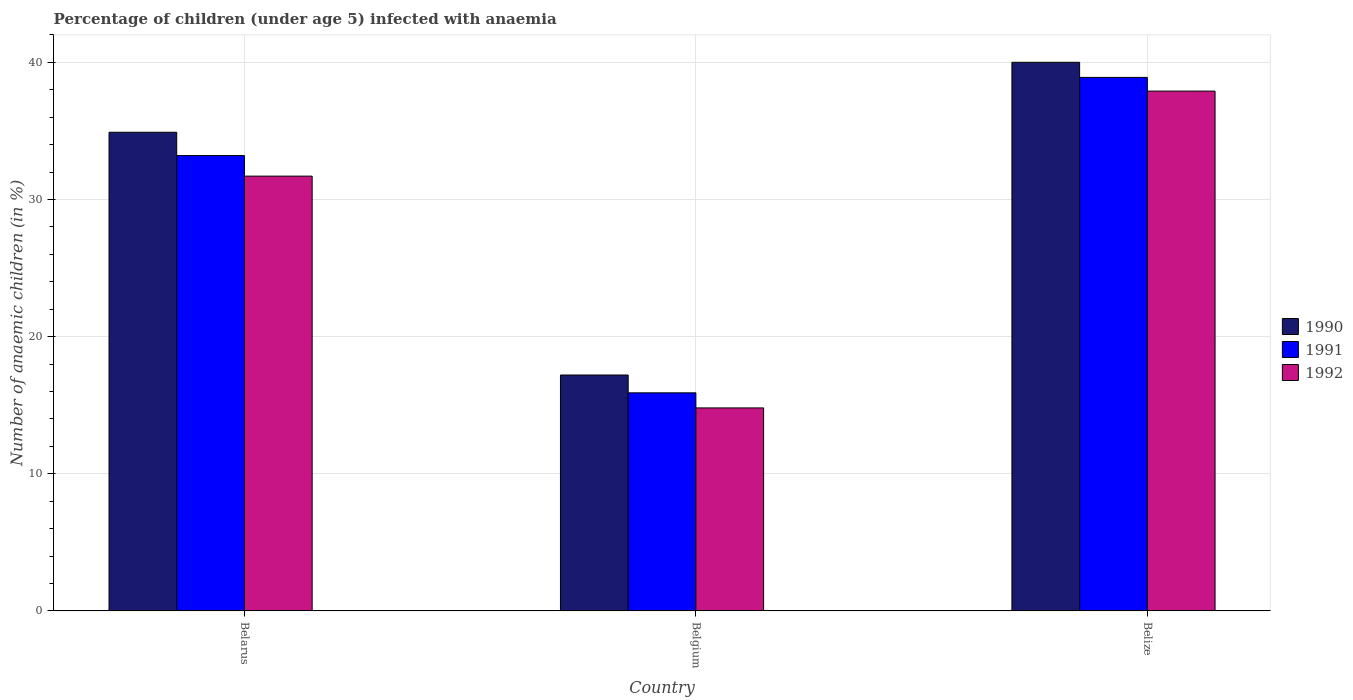Are the number of bars per tick equal to the number of legend labels?
Provide a short and direct response. Yes. How many bars are there on the 3rd tick from the left?
Keep it short and to the point. 3. How many bars are there on the 1st tick from the right?
Ensure brevity in your answer.  3. What is the label of the 3rd group of bars from the left?
Your answer should be very brief. Belize. What is the percentage of children infected with anaemia in in 1992 in Belize?
Provide a short and direct response. 37.9. Across all countries, what is the maximum percentage of children infected with anaemia in in 1992?
Make the answer very short. 37.9. Across all countries, what is the minimum percentage of children infected with anaemia in in 1992?
Your response must be concise. 14.8. In which country was the percentage of children infected with anaemia in in 1992 maximum?
Make the answer very short. Belize. What is the total percentage of children infected with anaemia in in 1990 in the graph?
Offer a very short reply. 92.1. What is the difference between the percentage of children infected with anaemia in in 1990 in Belarus and that in Belize?
Your answer should be very brief. -5.1. What is the average percentage of children infected with anaemia in in 1992 per country?
Ensure brevity in your answer.  28.13. What is the difference between the percentage of children infected with anaemia in of/in 1992 and percentage of children infected with anaemia in of/in 1990 in Belgium?
Provide a short and direct response. -2.4. In how many countries, is the percentage of children infected with anaemia in in 1991 greater than 40 %?
Your answer should be very brief. 0. What is the ratio of the percentage of children infected with anaemia in in 1990 in Belarus to that in Belize?
Provide a succinct answer. 0.87. Is the percentage of children infected with anaemia in in 1991 in Belarus less than that in Belgium?
Keep it short and to the point. No. What is the difference between the highest and the second highest percentage of children infected with anaemia in in 1990?
Ensure brevity in your answer.  22.8. What is the difference between the highest and the lowest percentage of children infected with anaemia in in 1992?
Ensure brevity in your answer.  23.1. What does the 3rd bar from the left in Belize represents?
Offer a terse response. 1992. What does the 3rd bar from the right in Belize represents?
Your answer should be very brief. 1990. Is it the case that in every country, the sum of the percentage of children infected with anaemia in in 1991 and percentage of children infected with anaemia in in 1990 is greater than the percentage of children infected with anaemia in in 1992?
Your response must be concise. Yes. Are all the bars in the graph horizontal?
Ensure brevity in your answer.  No. How many countries are there in the graph?
Give a very brief answer. 3. What is the difference between two consecutive major ticks on the Y-axis?
Your answer should be very brief. 10. Does the graph contain any zero values?
Provide a short and direct response. No. What is the title of the graph?
Provide a succinct answer. Percentage of children (under age 5) infected with anaemia. What is the label or title of the Y-axis?
Offer a terse response. Number of anaemic children (in %). What is the Number of anaemic children (in %) of 1990 in Belarus?
Make the answer very short. 34.9. What is the Number of anaemic children (in %) in 1991 in Belarus?
Offer a very short reply. 33.2. What is the Number of anaemic children (in %) in 1992 in Belarus?
Offer a very short reply. 31.7. What is the Number of anaemic children (in %) of 1990 in Belgium?
Ensure brevity in your answer.  17.2. What is the Number of anaemic children (in %) of 1991 in Belgium?
Your response must be concise. 15.9. What is the Number of anaemic children (in %) of 1992 in Belgium?
Your answer should be very brief. 14.8. What is the Number of anaemic children (in %) in 1990 in Belize?
Your answer should be compact. 40. What is the Number of anaemic children (in %) in 1991 in Belize?
Provide a succinct answer. 38.9. What is the Number of anaemic children (in %) of 1992 in Belize?
Provide a short and direct response. 37.9. Across all countries, what is the maximum Number of anaemic children (in %) of 1990?
Offer a very short reply. 40. Across all countries, what is the maximum Number of anaemic children (in %) of 1991?
Your answer should be very brief. 38.9. Across all countries, what is the maximum Number of anaemic children (in %) of 1992?
Provide a succinct answer. 37.9. Across all countries, what is the minimum Number of anaemic children (in %) in 1991?
Your response must be concise. 15.9. Across all countries, what is the minimum Number of anaemic children (in %) of 1992?
Ensure brevity in your answer.  14.8. What is the total Number of anaemic children (in %) of 1990 in the graph?
Give a very brief answer. 92.1. What is the total Number of anaemic children (in %) in 1991 in the graph?
Offer a terse response. 88. What is the total Number of anaemic children (in %) of 1992 in the graph?
Your answer should be compact. 84.4. What is the difference between the Number of anaemic children (in %) in 1990 in Belarus and that in Belgium?
Your answer should be compact. 17.7. What is the difference between the Number of anaemic children (in %) in 1991 in Belarus and that in Belgium?
Provide a succinct answer. 17.3. What is the difference between the Number of anaemic children (in %) of 1992 in Belarus and that in Belgium?
Your answer should be compact. 16.9. What is the difference between the Number of anaemic children (in %) of 1990 in Belarus and that in Belize?
Offer a terse response. -5.1. What is the difference between the Number of anaemic children (in %) of 1992 in Belarus and that in Belize?
Offer a very short reply. -6.2. What is the difference between the Number of anaemic children (in %) in 1990 in Belgium and that in Belize?
Provide a succinct answer. -22.8. What is the difference between the Number of anaemic children (in %) in 1991 in Belgium and that in Belize?
Ensure brevity in your answer.  -23. What is the difference between the Number of anaemic children (in %) in 1992 in Belgium and that in Belize?
Offer a very short reply. -23.1. What is the difference between the Number of anaemic children (in %) of 1990 in Belarus and the Number of anaemic children (in %) of 1992 in Belgium?
Keep it short and to the point. 20.1. What is the difference between the Number of anaemic children (in %) of 1991 in Belarus and the Number of anaemic children (in %) of 1992 in Belgium?
Provide a succinct answer. 18.4. What is the difference between the Number of anaemic children (in %) of 1990 in Belarus and the Number of anaemic children (in %) of 1991 in Belize?
Ensure brevity in your answer.  -4. What is the difference between the Number of anaemic children (in %) in 1991 in Belarus and the Number of anaemic children (in %) in 1992 in Belize?
Make the answer very short. -4.7. What is the difference between the Number of anaemic children (in %) of 1990 in Belgium and the Number of anaemic children (in %) of 1991 in Belize?
Keep it short and to the point. -21.7. What is the difference between the Number of anaemic children (in %) of 1990 in Belgium and the Number of anaemic children (in %) of 1992 in Belize?
Provide a short and direct response. -20.7. What is the average Number of anaemic children (in %) in 1990 per country?
Keep it short and to the point. 30.7. What is the average Number of anaemic children (in %) in 1991 per country?
Your answer should be compact. 29.33. What is the average Number of anaemic children (in %) in 1992 per country?
Provide a short and direct response. 28.13. What is the difference between the Number of anaemic children (in %) in 1990 and Number of anaemic children (in %) in 1991 in Belarus?
Keep it short and to the point. 1.7. What is the difference between the Number of anaemic children (in %) of 1990 and Number of anaemic children (in %) of 1991 in Belgium?
Make the answer very short. 1.3. What is the difference between the Number of anaemic children (in %) of 1990 and Number of anaemic children (in %) of 1992 in Belize?
Provide a short and direct response. 2.1. What is the ratio of the Number of anaemic children (in %) in 1990 in Belarus to that in Belgium?
Your response must be concise. 2.03. What is the ratio of the Number of anaemic children (in %) in 1991 in Belarus to that in Belgium?
Keep it short and to the point. 2.09. What is the ratio of the Number of anaemic children (in %) in 1992 in Belarus to that in Belgium?
Give a very brief answer. 2.14. What is the ratio of the Number of anaemic children (in %) of 1990 in Belarus to that in Belize?
Offer a terse response. 0.87. What is the ratio of the Number of anaemic children (in %) of 1991 in Belarus to that in Belize?
Make the answer very short. 0.85. What is the ratio of the Number of anaemic children (in %) in 1992 in Belarus to that in Belize?
Offer a very short reply. 0.84. What is the ratio of the Number of anaemic children (in %) of 1990 in Belgium to that in Belize?
Ensure brevity in your answer.  0.43. What is the ratio of the Number of anaemic children (in %) of 1991 in Belgium to that in Belize?
Offer a terse response. 0.41. What is the ratio of the Number of anaemic children (in %) in 1992 in Belgium to that in Belize?
Provide a succinct answer. 0.39. What is the difference between the highest and the second highest Number of anaemic children (in %) of 1990?
Provide a short and direct response. 5.1. What is the difference between the highest and the lowest Number of anaemic children (in %) of 1990?
Provide a short and direct response. 22.8. What is the difference between the highest and the lowest Number of anaemic children (in %) of 1992?
Your answer should be compact. 23.1. 